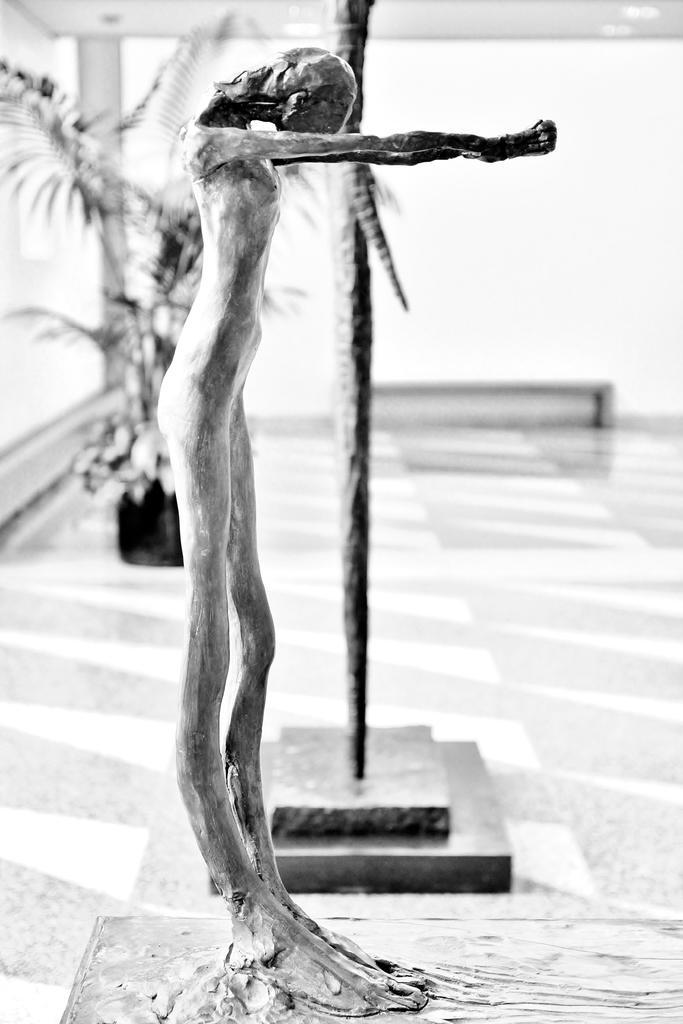In one or two sentences, can you explain what this image depicts? Front we can see statue. Background it is blurry and we can see plant. 